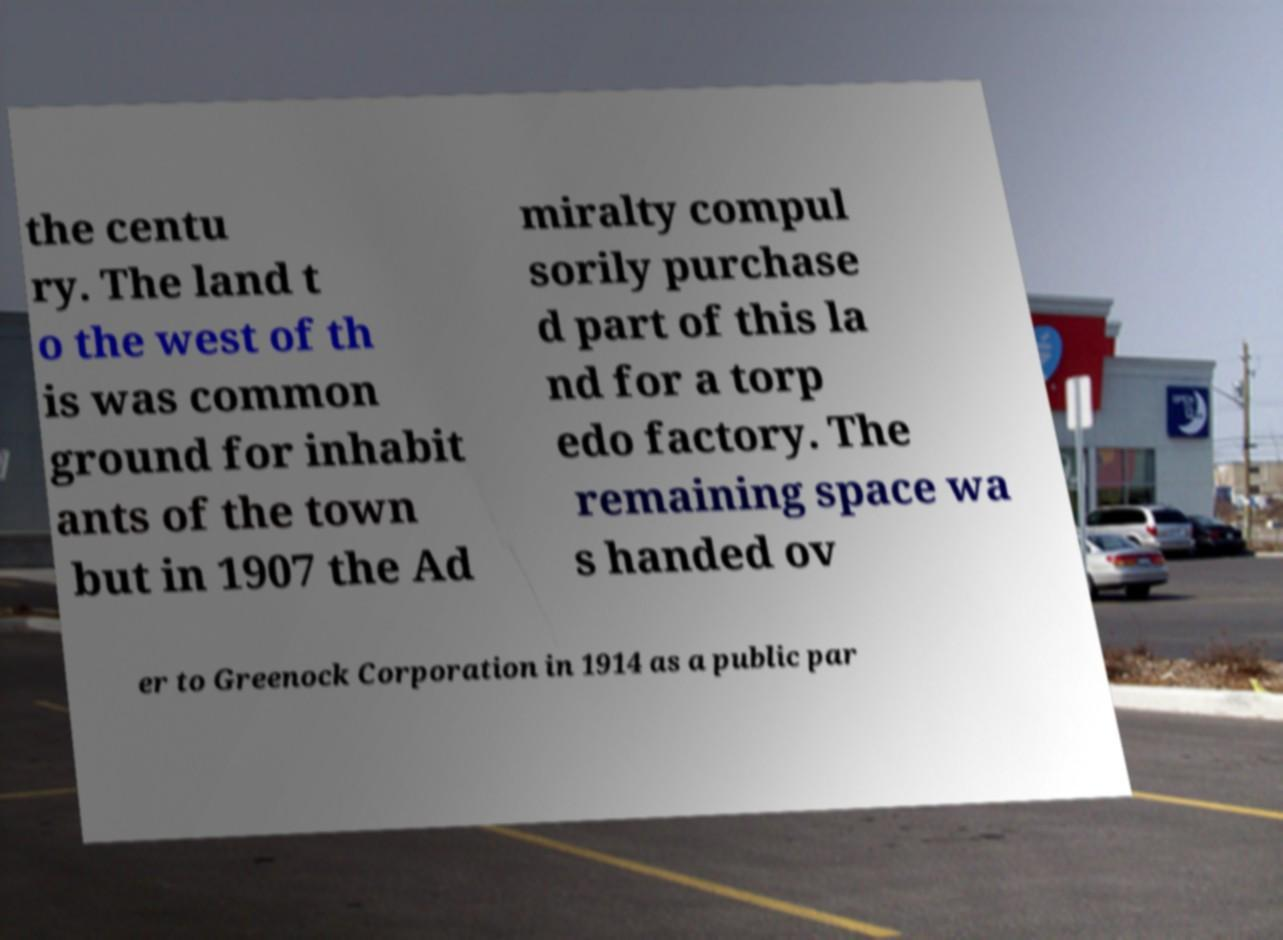I need the written content from this picture converted into text. Can you do that? the centu ry. The land t o the west of th is was common ground for inhabit ants of the town but in 1907 the Ad miralty compul sorily purchase d part of this la nd for a torp edo factory. The remaining space wa s handed ov er to Greenock Corporation in 1914 as a public par 